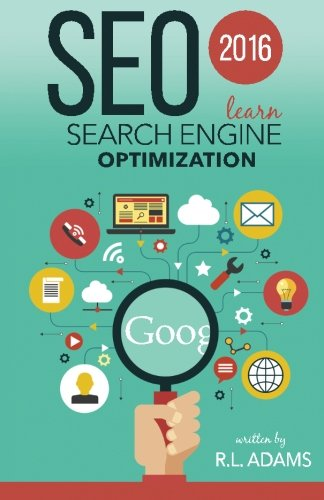What is the title of this book? The title of the book is 'SEO 2016: Learn Search Engine Optimization,' a guide that focuses on the latest best practices in SEO for the year 2016. 